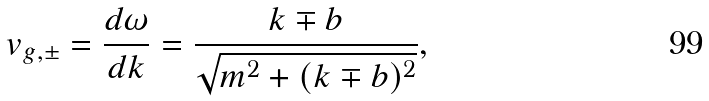Convert formula to latex. <formula><loc_0><loc_0><loc_500><loc_500>v _ { g , \pm } = \frac { d \omega } { d k } = \frac { k \mp b } { \sqrt { m ^ { 2 } + ( k \mp b ) ^ { 2 } } } ,</formula> 